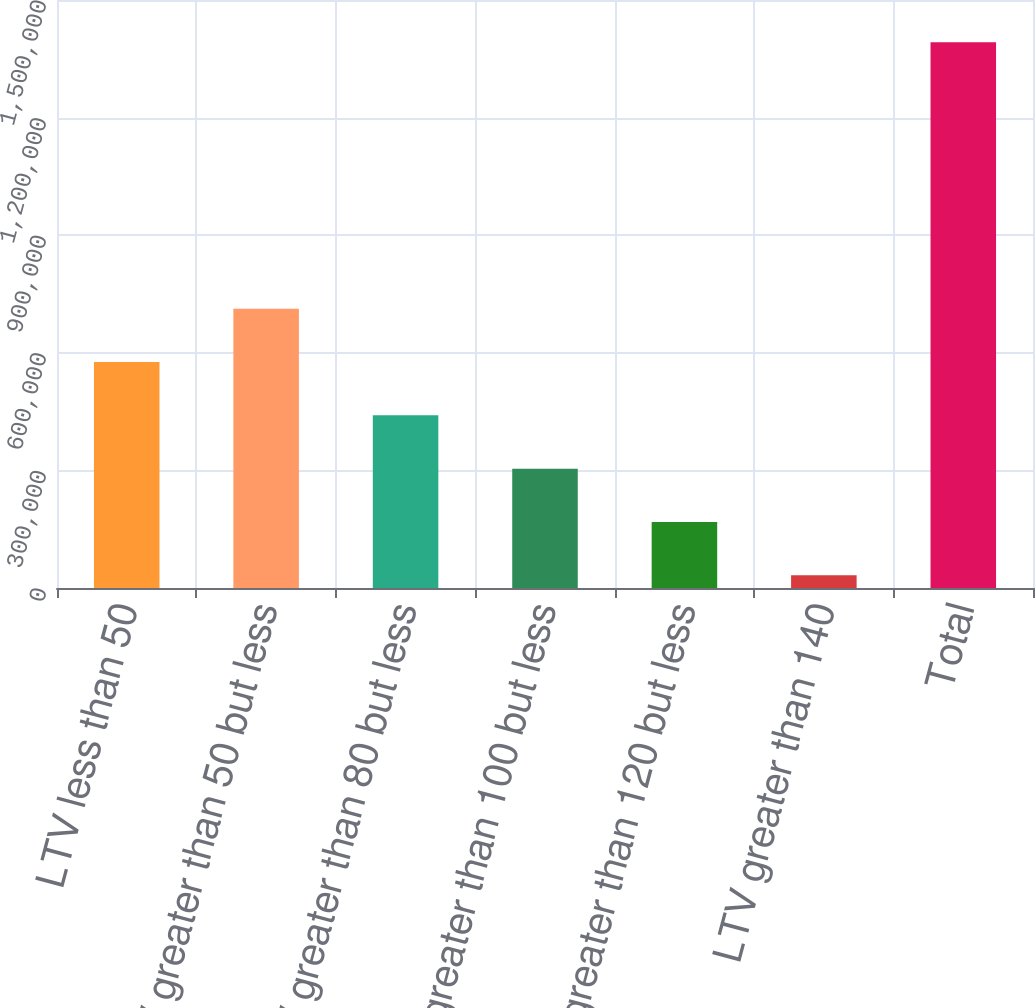Convert chart. <chart><loc_0><loc_0><loc_500><loc_500><bar_chart><fcel>LTV less than 50<fcel>LTV greater than 50 but less<fcel>LTV greater than 80 but less<fcel>LTV greater than 100 but less<fcel>LTV greater than 120 but less<fcel>LTV greater than 140<fcel>Total<nl><fcel>576458<fcel>712452<fcel>440464<fcel>304470<fcel>168476<fcel>32482<fcel>1.39242e+06<nl></chart> 